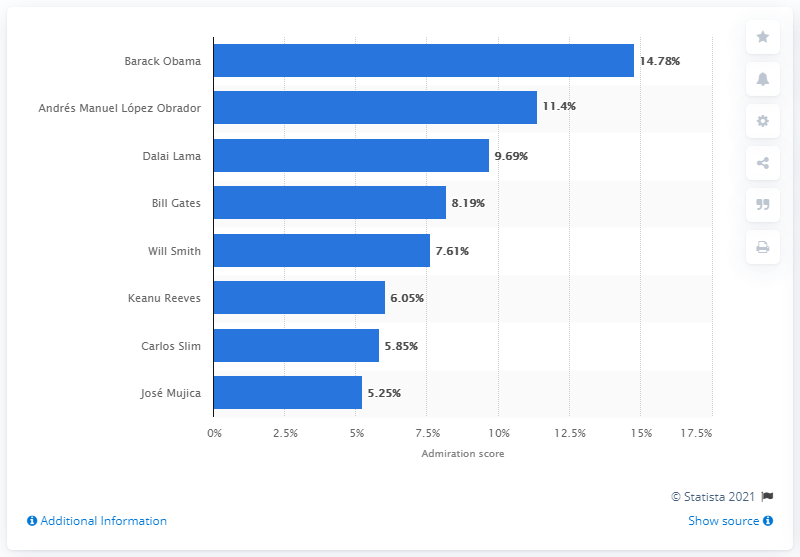Identify some key points in this picture. Barack Obama was voted the most admired man in the world. 